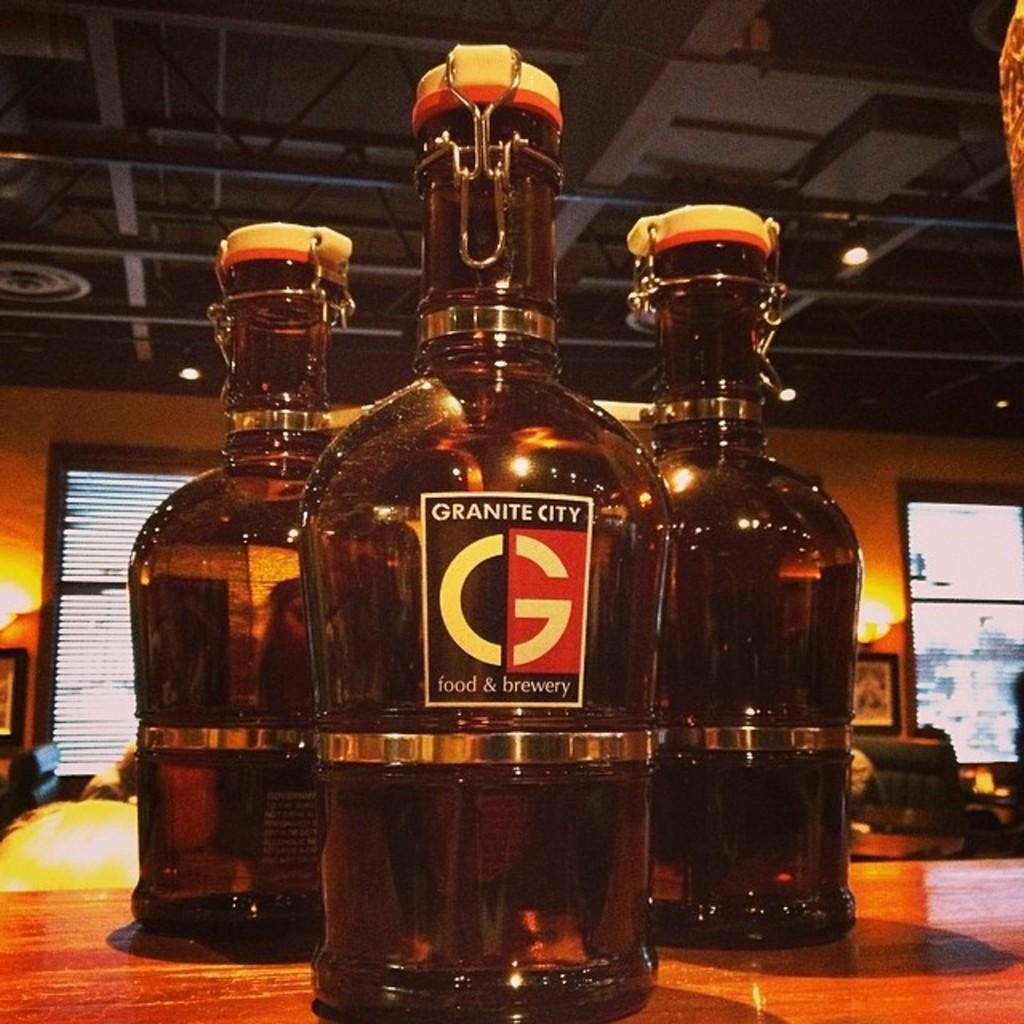<image>
Describe the image concisely. 3 bottles on a table with Granite City Food and Brewery written on the label. 